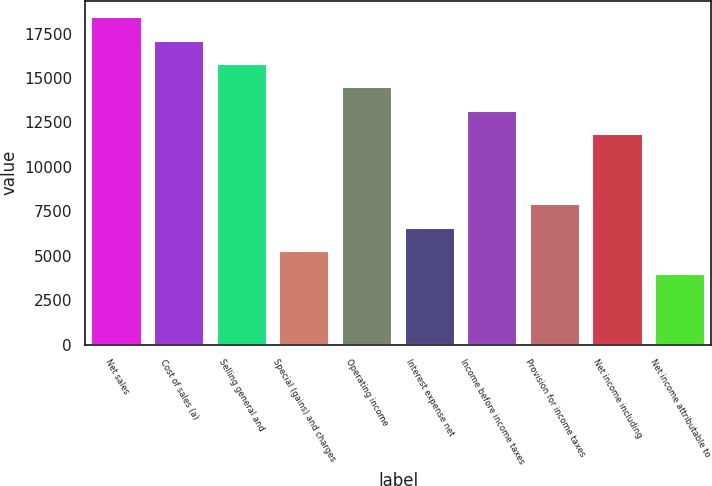<chart> <loc_0><loc_0><loc_500><loc_500><bar_chart><fcel>Net sales<fcel>Cost of sales (a)<fcel>Selling general and<fcel>Special (gains) and charges<fcel>Operating income<fcel>Interest expense net<fcel>Income before income taxes<fcel>Provision for income taxes<fcel>Net income including<fcel>Net income attributable to<nl><fcel>18412.3<fcel>17097.5<fcel>15782.6<fcel>5263.62<fcel>14467.7<fcel>6578.49<fcel>13152.8<fcel>7893.36<fcel>11838<fcel>3948.75<nl></chart> 